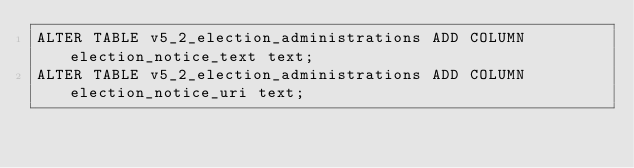Convert code to text. <code><loc_0><loc_0><loc_500><loc_500><_SQL_>ALTER TABLE v5_2_election_administrations ADD COLUMN election_notice_text text;
ALTER TABLE v5_2_election_administrations ADD COLUMN election_notice_uri text;
</code> 